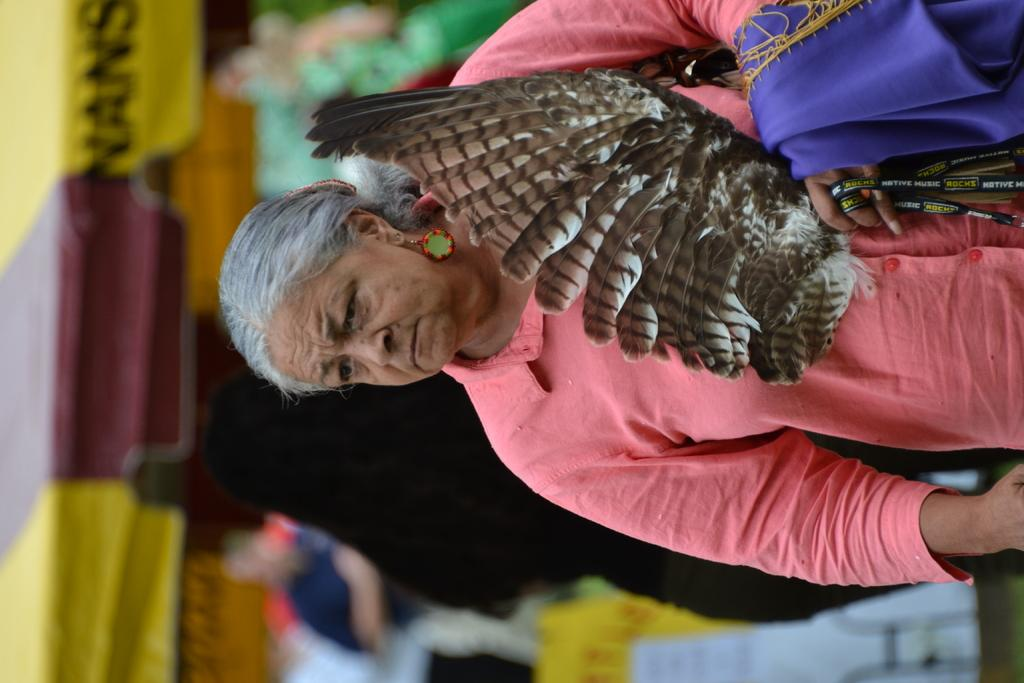What is the main subject of the image? There is a woman in the image. What is the woman doing in the image? The woman is standing in the image. What is the woman holding in the image? The woman is holding some objects in the image. What type of lunch is the woman eating in the image? There is no lunch present in the image; the woman is holding some objects. How many times has the woman received approval in the image? There is no indication of approval or any related process in the image. 